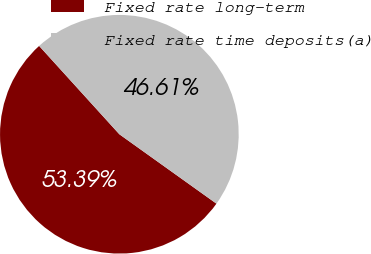<chart> <loc_0><loc_0><loc_500><loc_500><pie_chart><fcel>Fixed rate long-term<fcel>Fixed rate time deposits(a)<nl><fcel>53.39%<fcel>46.61%<nl></chart> 